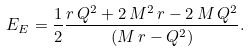<formula> <loc_0><loc_0><loc_500><loc_500>E _ { E } = \frac { 1 } { 2 } \frac { r \, Q ^ { 2 } + 2 \, M ^ { 2 } \, r - 2 \, M \, Q ^ { 2 } } { ( M \, r - Q ^ { 2 } ) } .</formula> 